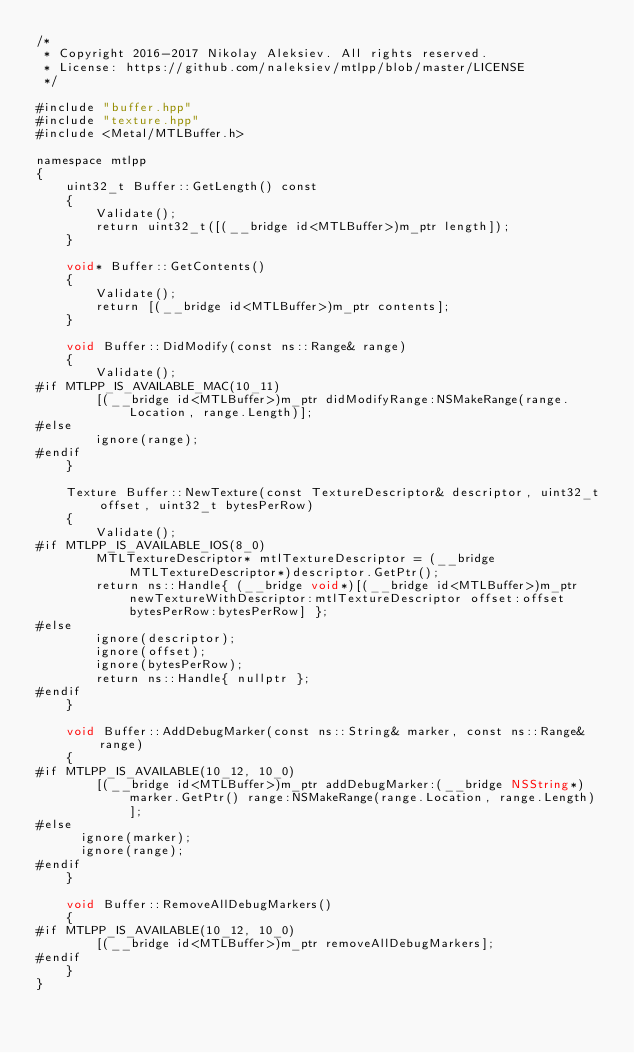Convert code to text. <code><loc_0><loc_0><loc_500><loc_500><_ObjectiveC_>/*
 * Copyright 2016-2017 Nikolay Aleksiev. All rights reserved.
 * License: https://github.com/naleksiev/mtlpp/blob/master/LICENSE
 */

#include "buffer.hpp"
#include "texture.hpp"
#include <Metal/MTLBuffer.h>

namespace mtlpp
{
    uint32_t Buffer::GetLength() const
    {
        Validate();
        return uint32_t([(__bridge id<MTLBuffer>)m_ptr length]);
    }

    void* Buffer::GetContents()
    {
        Validate();
        return [(__bridge id<MTLBuffer>)m_ptr contents];
    }

    void Buffer::DidModify(const ns::Range& range)
    {
        Validate();
#if MTLPP_IS_AVAILABLE_MAC(10_11)
        [(__bridge id<MTLBuffer>)m_ptr didModifyRange:NSMakeRange(range.Location, range.Length)];
#else
        ignore(range);
#endif
    }

    Texture Buffer::NewTexture(const TextureDescriptor& descriptor, uint32_t offset, uint32_t bytesPerRow)
    {
        Validate();
#if MTLPP_IS_AVAILABLE_IOS(8_0)
        MTLTextureDescriptor* mtlTextureDescriptor = (__bridge MTLTextureDescriptor*)descriptor.GetPtr();
        return ns::Handle{ (__bridge void*)[(__bridge id<MTLBuffer>)m_ptr newTextureWithDescriptor:mtlTextureDescriptor offset:offset bytesPerRow:bytesPerRow] };
#else
        ignore(descriptor);
        ignore(offset);
        ignore(bytesPerRow);
        return ns::Handle{ nullptr };
#endif
    }

    void Buffer::AddDebugMarker(const ns::String& marker, const ns::Range& range)
    {
#if MTLPP_IS_AVAILABLE(10_12, 10_0)
        [(__bridge id<MTLBuffer>)m_ptr addDebugMarker:(__bridge NSString*)marker.GetPtr() range:NSMakeRange(range.Location, range.Length)];
#else
      ignore(marker);
      ignore(range);
#endif
    }

    void Buffer::RemoveAllDebugMarkers()
    {
#if MTLPP_IS_AVAILABLE(10_12, 10_0)
        [(__bridge id<MTLBuffer>)m_ptr removeAllDebugMarkers];
#endif
    }
}
</code> 